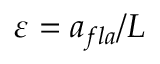<formula> <loc_0><loc_0><loc_500><loc_500>\varepsilon = a _ { f l a } / L</formula> 